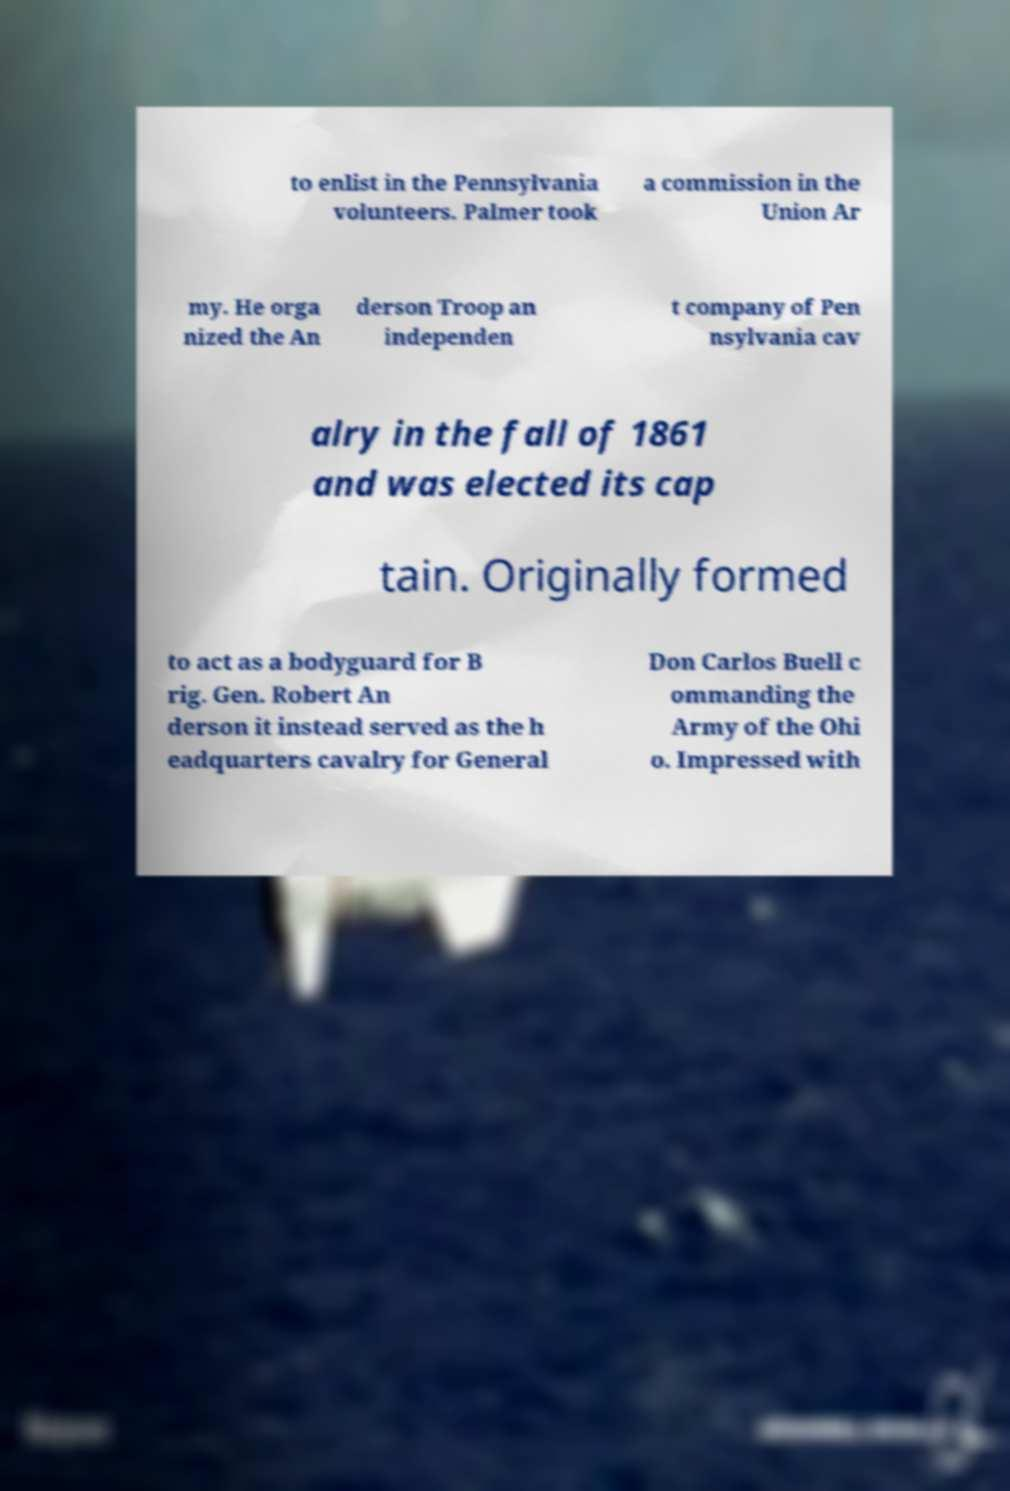Please read and relay the text visible in this image. What does it say? to enlist in the Pennsylvania volunteers. Palmer took a commission in the Union Ar my. He orga nized the An derson Troop an independen t company of Pen nsylvania cav alry in the fall of 1861 and was elected its cap tain. Originally formed to act as a bodyguard for B rig. Gen. Robert An derson it instead served as the h eadquarters cavalry for General Don Carlos Buell c ommanding the Army of the Ohi o. Impressed with 